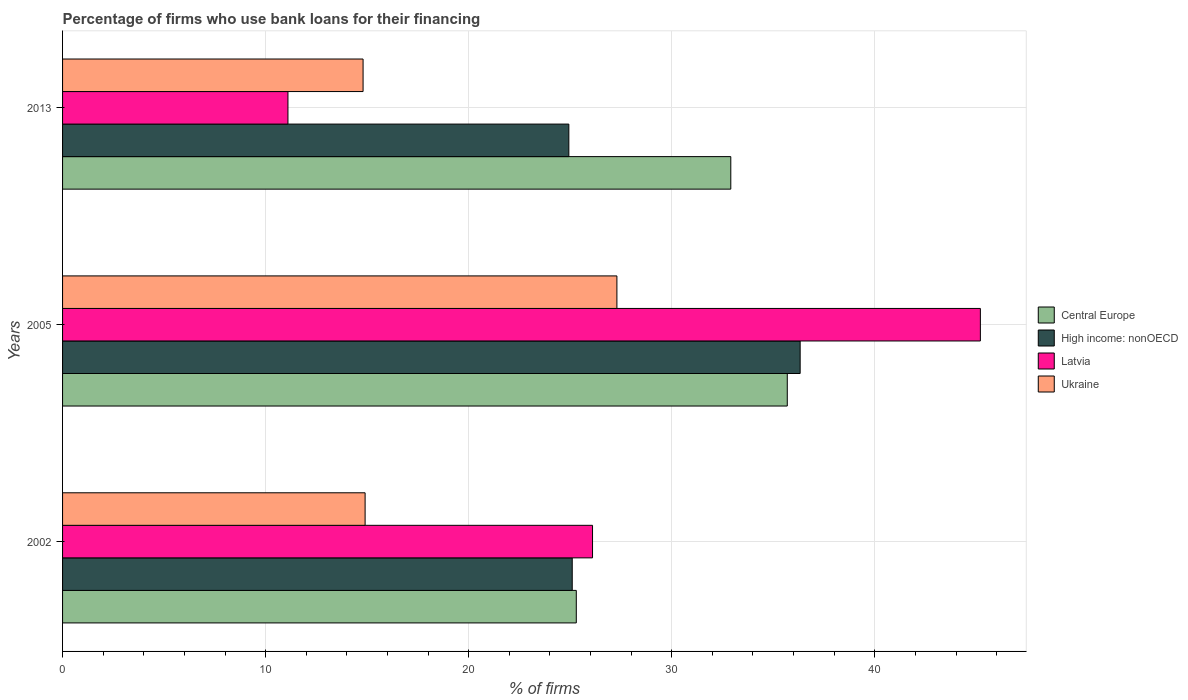How many groups of bars are there?
Offer a terse response. 3. Are the number of bars per tick equal to the number of legend labels?
Offer a terse response. Yes. Are the number of bars on each tick of the Y-axis equal?
Ensure brevity in your answer.  Yes. How many bars are there on the 2nd tick from the bottom?
Offer a terse response. 4. In how many cases, is the number of bars for a given year not equal to the number of legend labels?
Keep it short and to the point. 0. What is the percentage of firms who use bank loans for their financing in High income: nonOECD in 2013?
Keep it short and to the point. 24.93. Across all years, what is the maximum percentage of firms who use bank loans for their financing in High income: nonOECD?
Give a very brief answer. 36.33. Across all years, what is the minimum percentage of firms who use bank loans for their financing in Ukraine?
Offer a terse response. 14.8. What is the total percentage of firms who use bank loans for their financing in Central Europe in the graph?
Your answer should be compact. 93.9. What is the difference between the percentage of firms who use bank loans for their financing in Latvia in 2005 and that in 2013?
Your response must be concise. 34.1. What is the difference between the percentage of firms who use bank loans for their financing in Ukraine in 2005 and the percentage of firms who use bank loans for their financing in Central Europe in 2013?
Keep it short and to the point. -5.61. What is the average percentage of firms who use bank loans for their financing in Central Europe per year?
Offer a terse response. 31.3. In the year 2002, what is the difference between the percentage of firms who use bank loans for their financing in Central Europe and percentage of firms who use bank loans for their financing in High income: nonOECD?
Make the answer very short. 0.2. In how many years, is the percentage of firms who use bank loans for their financing in High income: nonOECD greater than 28 %?
Offer a terse response. 1. What is the ratio of the percentage of firms who use bank loans for their financing in Latvia in 2005 to that in 2013?
Keep it short and to the point. 4.07. Is the percentage of firms who use bank loans for their financing in Central Europe in 2002 less than that in 2013?
Keep it short and to the point. Yes. What is the difference between the highest and the second highest percentage of firms who use bank loans for their financing in High income: nonOECD?
Provide a short and direct response. 11.23. What is the difference between the highest and the lowest percentage of firms who use bank loans for their financing in Central Europe?
Make the answer very short. 10.39. Is it the case that in every year, the sum of the percentage of firms who use bank loans for their financing in Latvia and percentage of firms who use bank loans for their financing in High income: nonOECD is greater than the sum of percentage of firms who use bank loans for their financing in Central Europe and percentage of firms who use bank loans for their financing in Ukraine?
Provide a succinct answer. No. What does the 3rd bar from the top in 2013 represents?
Offer a terse response. High income: nonOECD. What does the 1st bar from the bottom in 2013 represents?
Give a very brief answer. Central Europe. Is it the case that in every year, the sum of the percentage of firms who use bank loans for their financing in Latvia and percentage of firms who use bank loans for their financing in Central Europe is greater than the percentage of firms who use bank loans for their financing in High income: nonOECD?
Your answer should be very brief. Yes. How many bars are there?
Give a very brief answer. 12. How many years are there in the graph?
Give a very brief answer. 3. What is the difference between two consecutive major ticks on the X-axis?
Provide a short and direct response. 10. Does the graph contain any zero values?
Provide a succinct answer. No. Does the graph contain grids?
Your answer should be compact. Yes. Where does the legend appear in the graph?
Offer a terse response. Center right. How many legend labels are there?
Give a very brief answer. 4. How are the legend labels stacked?
Offer a terse response. Vertical. What is the title of the graph?
Your response must be concise. Percentage of firms who use bank loans for their financing. Does "Guatemala" appear as one of the legend labels in the graph?
Give a very brief answer. No. What is the label or title of the X-axis?
Offer a very short reply. % of firms. What is the % of firms of Central Europe in 2002?
Your answer should be compact. 25.3. What is the % of firms of High income: nonOECD in 2002?
Give a very brief answer. 25.1. What is the % of firms of Latvia in 2002?
Offer a terse response. 26.1. What is the % of firms of Ukraine in 2002?
Provide a succinct answer. 14.9. What is the % of firms of Central Europe in 2005?
Give a very brief answer. 35.69. What is the % of firms in High income: nonOECD in 2005?
Offer a very short reply. 36.33. What is the % of firms in Latvia in 2005?
Your response must be concise. 45.2. What is the % of firms in Ukraine in 2005?
Your response must be concise. 27.3. What is the % of firms of Central Europe in 2013?
Your answer should be very brief. 32.91. What is the % of firms in High income: nonOECD in 2013?
Your response must be concise. 24.93. What is the % of firms in Latvia in 2013?
Your answer should be compact. 11.1. Across all years, what is the maximum % of firms in Central Europe?
Keep it short and to the point. 35.69. Across all years, what is the maximum % of firms in High income: nonOECD?
Offer a very short reply. 36.33. Across all years, what is the maximum % of firms in Latvia?
Your answer should be very brief. 45.2. Across all years, what is the maximum % of firms in Ukraine?
Offer a terse response. 27.3. Across all years, what is the minimum % of firms of Central Europe?
Ensure brevity in your answer.  25.3. Across all years, what is the minimum % of firms of High income: nonOECD?
Your answer should be very brief. 24.93. Across all years, what is the minimum % of firms in Ukraine?
Keep it short and to the point. 14.8. What is the total % of firms of Central Europe in the graph?
Make the answer very short. 93.9. What is the total % of firms in High income: nonOECD in the graph?
Keep it short and to the point. 86.36. What is the total % of firms in Latvia in the graph?
Provide a succinct answer. 82.4. What is the difference between the % of firms in Central Europe in 2002 and that in 2005?
Your answer should be compact. -10.39. What is the difference between the % of firms in High income: nonOECD in 2002 and that in 2005?
Provide a short and direct response. -11.22. What is the difference between the % of firms of Latvia in 2002 and that in 2005?
Your answer should be compact. -19.1. What is the difference between the % of firms in Ukraine in 2002 and that in 2005?
Provide a succinct answer. -12.4. What is the difference between the % of firms in Central Europe in 2002 and that in 2013?
Keep it short and to the point. -7.61. What is the difference between the % of firms in Ukraine in 2002 and that in 2013?
Give a very brief answer. 0.1. What is the difference between the % of firms in Central Europe in 2005 and that in 2013?
Give a very brief answer. 2.78. What is the difference between the % of firms of High income: nonOECD in 2005 and that in 2013?
Ensure brevity in your answer.  11.39. What is the difference between the % of firms of Latvia in 2005 and that in 2013?
Keep it short and to the point. 34.1. What is the difference between the % of firms in Central Europe in 2002 and the % of firms in High income: nonOECD in 2005?
Ensure brevity in your answer.  -11.03. What is the difference between the % of firms in Central Europe in 2002 and the % of firms in Latvia in 2005?
Your answer should be compact. -19.9. What is the difference between the % of firms in High income: nonOECD in 2002 and the % of firms in Latvia in 2005?
Offer a terse response. -20.1. What is the difference between the % of firms of High income: nonOECD in 2002 and the % of firms of Ukraine in 2005?
Ensure brevity in your answer.  -2.2. What is the difference between the % of firms of Central Europe in 2002 and the % of firms of High income: nonOECD in 2013?
Provide a succinct answer. 0.37. What is the difference between the % of firms of Central Europe in 2002 and the % of firms of Latvia in 2013?
Ensure brevity in your answer.  14.2. What is the difference between the % of firms of Central Europe in 2002 and the % of firms of Ukraine in 2013?
Keep it short and to the point. 10.5. What is the difference between the % of firms of Latvia in 2002 and the % of firms of Ukraine in 2013?
Make the answer very short. 11.3. What is the difference between the % of firms in Central Europe in 2005 and the % of firms in High income: nonOECD in 2013?
Your answer should be very brief. 10.76. What is the difference between the % of firms of Central Europe in 2005 and the % of firms of Latvia in 2013?
Provide a succinct answer. 24.59. What is the difference between the % of firms in Central Europe in 2005 and the % of firms in Ukraine in 2013?
Provide a short and direct response. 20.89. What is the difference between the % of firms in High income: nonOECD in 2005 and the % of firms in Latvia in 2013?
Your response must be concise. 25.23. What is the difference between the % of firms in High income: nonOECD in 2005 and the % of firms in Ukraine in 2013?
Your answer should be very brief. 21.52. What is the difference between the % of firms in Latvia in 2005 and the % of firms in Ukraine in 2013?
Keep it short and to the point. 30.4. What is the average % of firms in Central Europe per year?
Your answer should be compact. 31.3. What is the average % of firms in High income: nonOECD per year?
Your answer should be very brief. 28.79. What is the average % of firms in Latvia per year?
Ensure brevity in your answer.  27.47. What is the average % of firms in Ukraine per year?
Ensure brevity in your answer.  19. In the year 2002, what is the difference between the % of firms of Central Europe and % of firms of Latvia?
Provide a short and direct response. -0.8. In the year 2002, what is the difference between the % of firms of Central Europe and % of firms of Ukraine?
Your answer should be very brief. 10.4. In the year 2002, what is the difference between the % of firms in High income: nonOECD and % of firms in Ukraine?
Provide a short and direct response. 10.2. In the year 2005, what is the difference between the % of firms of Central Europe and % of firms of High income: nonOECD?
Your answer should be compact. -0.63. In the year 2005, what is the difference between the % of firms in Central Europe and % of firms in Latvia?
Provide a succinct answer. -9.51. In the year 2005, what is the difference between the % of firms of Central Europe and % of firms of Ukraine?
Give a very brief answer. 8.39. In the year 2005, what is the difference between the % of firms in High income: nonOECD and % of firms in Latvia?
Offer a very short reply. -8.88. In the year 2005, what is the difference between the % of firms in High income: nonOECD and % of firms in Ukraine?
Your response must be concise. 9.03. In the year 2013, what is the difference between the % of firms in Central Europe and % of firms in High income: nonOECD?
Keep it short and to the point. 7.98. In the year 2013, what is the difference between the % of firms of Central Europe and % of firms of Latvia?
Keep it short and to the point. 21.81. In the year 2013, what is the difference between the % of firms of Central Europe and % of firms of Ukraine?
Provide a succinct answer. 18.11. In the year 2013, what is the difference between the % of firms of High income: nonOECD and % of firms of Latvia?
Provide a short and direct response. 13.83. In the year 2013, what is the difference between the % of firms in High income: nonOECD and % of firms in Ukraine?
Give a very brief answer. 10.13. In the year 2013, what is the difference between the % of firms in Latvia and % of firms in Ukraine?
Your response must be concise. -3.7. What is the ratio of the % of firms of Central Europe in 2002 to that in 2005?
Make the answer very short. 0.71. What is the ratio of the % of firms of High income: nonOECD in 2002 to that in 2005?
Keep it short and to the point. 0.69. What is the ratio of the % of firms of Latvia in 2002 to that in 2005?
Keep it short and to the point. 0.58. What is the ratio of the % of firms in Ukraine in 2002 to that in 2005?
Your response must be concise. 0.55. What is the ratio of the % of firms in Central Europe in 2002 to that in 2013?
Offer a terse response. 0.77. What is the ratio of the % of firms of Latvia in 2002 to that in 2013?
Provide a short and direct response. 2.35. What is the ratio of the % of firms of Ukraine in 2002 to that in 2013?
Your answer should be very brief. 1.01. What is the ratio of the % of firms of Central Europe in 2005 to that in 2013?
Ensure brevity in your answer.  1.08. What is the ratio of the % of firms of High income: nonOECD in 2005 to that in 2013?
Offer a terse response. 1.46. What is the ratio of the % of firms in Latvia in 2005 to that in 2013?
Offer a terse response. 4.07. What is the ratio of the % of firms in Ukraine in 2005 to that in 2013?
Provide a short and direct response. 1.84. What is the difference between the highest and the second highest % of firms of Central Europe?
Your answer should be very brief. 2.78. What is the difference between the highest and the second highest % of firms of High income: nonOECD?
Keep it short and to the point. 11.22. What is the difference between the highest and the second highest % of firms in Ukraine?
Give a very brief answer. 12.4. What is the difference between the highest and the lowest % of firms of Central Europe?
Offer a very short reply. 10.39. What is the difference between the highest and the lowest % of firms in High income: nonOECD?
Your answer should be very brief. 11.39. What is the difference between the highest and the lowest % of firms of Latvia?
Give a very brief answer. 34.1. What is the difference between the highest and the lowest % of firms in Ukraine?
Provide a succinct answer. 12.5. 